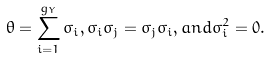<formula> <loc_0><loc_0><loc_500><loc_500>\theta = \sum _ { i = 1 } ^ { g _ { Y } } \sigma _ { i } , \sigma _ { i } \sigma _ { j } = \sigma _ { j } \sigma _ { i } , a n d \sigma _ { i } ^ { 2 } = 0 .</formula> 